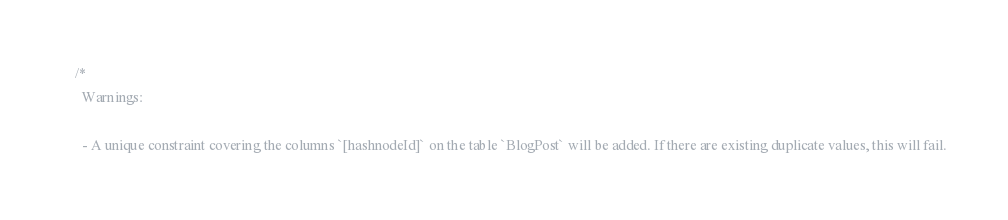Convert code to text. <code><loc_0><loc_0><loc_500><loc_500><_SQL_>/*
  Warnings:

  - A unique constraint covering the columns `[hashnodeId]` on the table `BlogPost` will be added. If there are existing duplicate values, this will fail.
</code> 